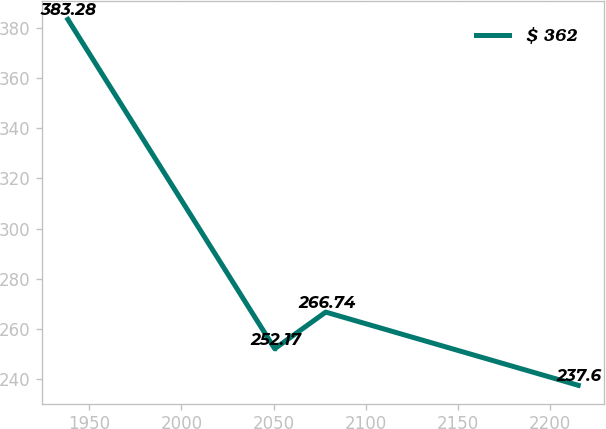Convert chart to OTSL. <chart><loc_0><loc_0><loc_500><loc_500><line_chart><ecel><fcel>$ 362<nl><fcel>1938.4<fcel>383.28<nl><fcel>2050.62<fcel>252.17<nl><fcel>2078.31<fcel>266.74<nl><fcel>2215.29<fcel>237.6<nl></chart> 